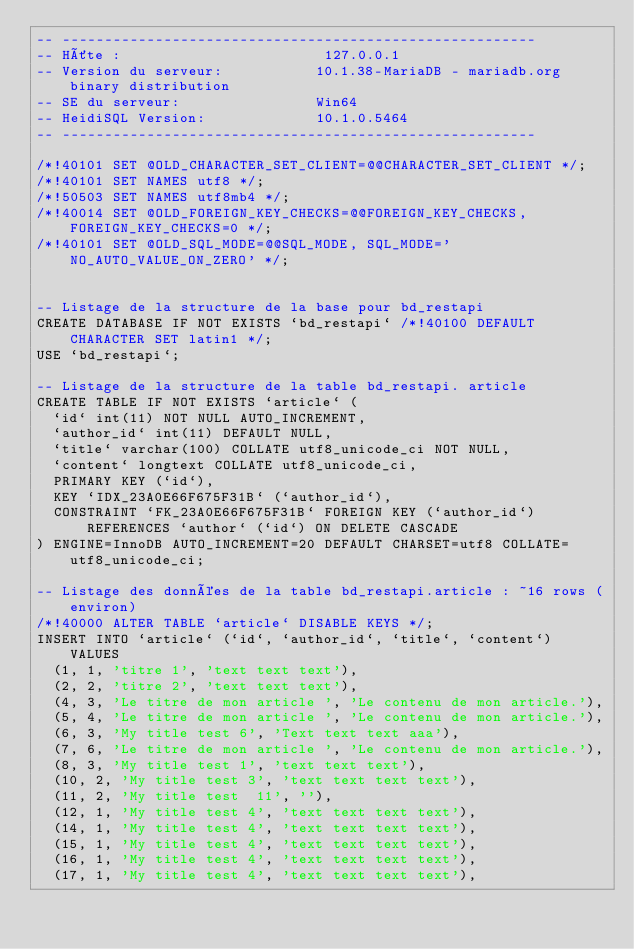Convert code to text. <code><loc_0><loc_0><loc_500><loc_500><_SQL_>-- --------------------------------------------------------
-- Hôte :                        127.0.0.1
-- Version du serveur:           10.1.38-MariaDB - mariadb.org binary distribution
-- SE du serveur:                Win64
-- HeidiSQL Version:             10.1.0.5464
-- --------------------------------------------------------

/*!40101 SET @OLD_CHARACTER_SET_CLIENT=@@CHARACTER_SET_CLIENT */;
/*!40101 SET NAMES utf8 */;
/*!50503 SET NAMES utf8mb4 */;
/*!40014 SET @OLD_FOREIGN_KEY_CHECKS=@@FOREIGN_KEY_CHECKS, FOREIGN_KEY_CHECKS=0 */;
/*!40101 SET @OLD_SQL_MODE=@@SQL_MODE, SQL_MODE='NO_AUTO_VALUE_ON_ZERO' */;


-- Listage de la structure de la base pour bd_restapi
CREATE DATABASE IF NOT EXISTS `bd_restapi` /*!40100 DEFAULT CHARACTER SET latin1 */;
USE `bd_restapi`;

-- Listage de la structure de la table bd_restapi. article
CREATE TABLE IF NOT EXISTS `article` (
  `id` int(11) NOT NULL AUTO_INCREMENT,
  `author_id` int(11) DEFAULT NULL,
  `title` varchar(100) COLLATE utf8_unicode_ci NOT NULL,
  `content` longtext COLLATE utf8_unicode_ci,
  PRIMARY KEY (`id`),
  KEY `IDX_23A0E66F675F31B` (`author_id`),
  CONSTRAINT `FK_23A0E66F675F31B` FOREIGN KEY (`author_id`) REFERENCES `author` (`id`) ON DELETE CASCADE
) ENGINE=InnoDB AUTO_INCREMENT=20 DEFAULT CHARSET=utf8 COLLATE=utf8_unicode_ci;

-- Listage des données de la table bd_restapi.article : ~16 rows (environ)
/*!40000 ALTER TABLE `article` DISABLE KEYS */;
INSERT INTO `article` (`id`, `author_id`, `title`, `content`) VALUES
	(1, 1, 'titre 1', 'text text text'),
	(2, 2, 'titre 2', 'text text text'),
	(4, 3, 'Le titre de mon article ', 'Le contenu de mon article.'),
	(5, 4, 'Le titre de mon article ', 'Le contenu de mon article.'),
	(6, 3, 'My title test 6', 'Text text text aaa'),
	(7, 6, 'Le titre de mon article ', 'Le contenu de mon article.'),
	(8, 3, 'My title test 1', 'text text text'),
	(10, 2, 'My title test 3', 'text text text text'),
	(11, 2, 'My title test  11', ''),
	(12, 1, 'My title test 4', 'text text text text'),
	(14, 1, 'My title test 4', 'text text text text'),
	(15, 1, 'My title test 4', 'text text text text'),
	(16, 1, 'My title test 4', 'text text text text'),
	(17, 1, 'My title test 4', 'text text text text'),</code> 